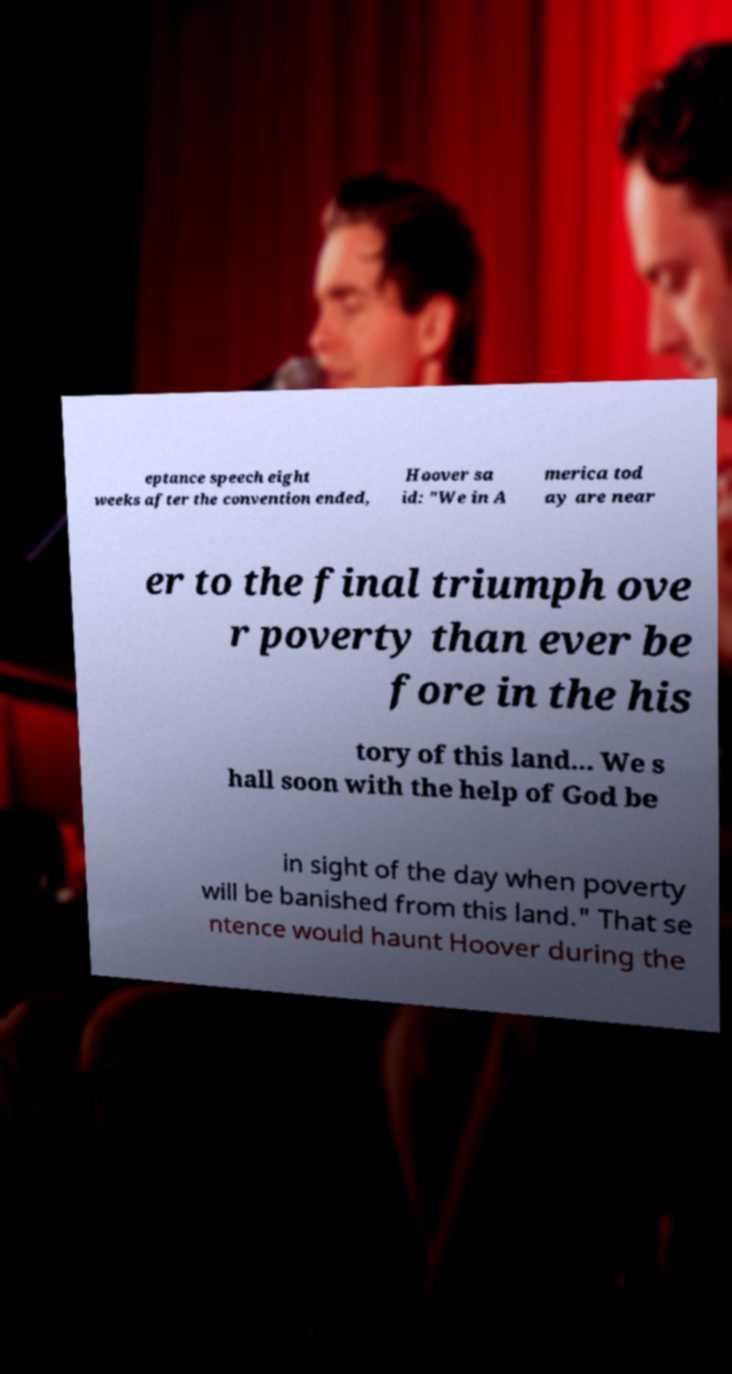I need the written content from this picture converted into text. Can you do that? eptance speech eight weeks after the convention ended, Hoover sa id: "We in A merica tod ay are near er to the final triumph ove r poverty than ever be fore in the his tory of this land... We s hall soon with the help of God be in sight of the day when poverty will be banished from this land." That se ntence would haunt Hoover during the 